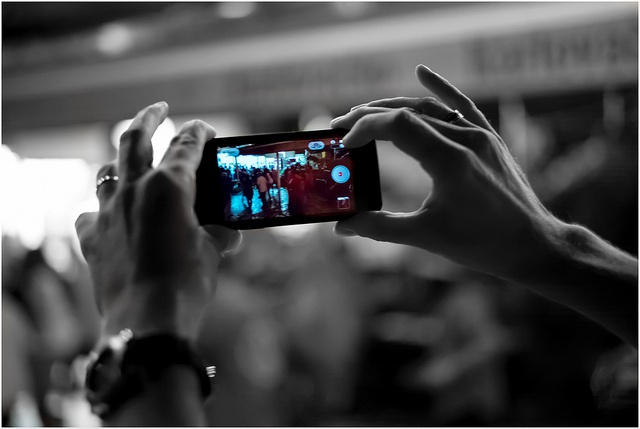Describe the objects in this image and their specific colors. I can see people in white, black, gray, darkgray, and lightgray tones and cell phone in white, black, maroon, gray, and lightblue tones in this image. 